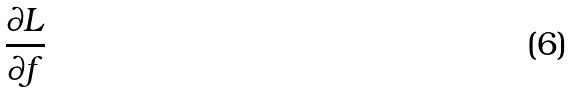Convert formula to latex. <formula><loc_0><loc_0><loc_500><loc_500>\frac { \partial L } { \partial f }</formula> 